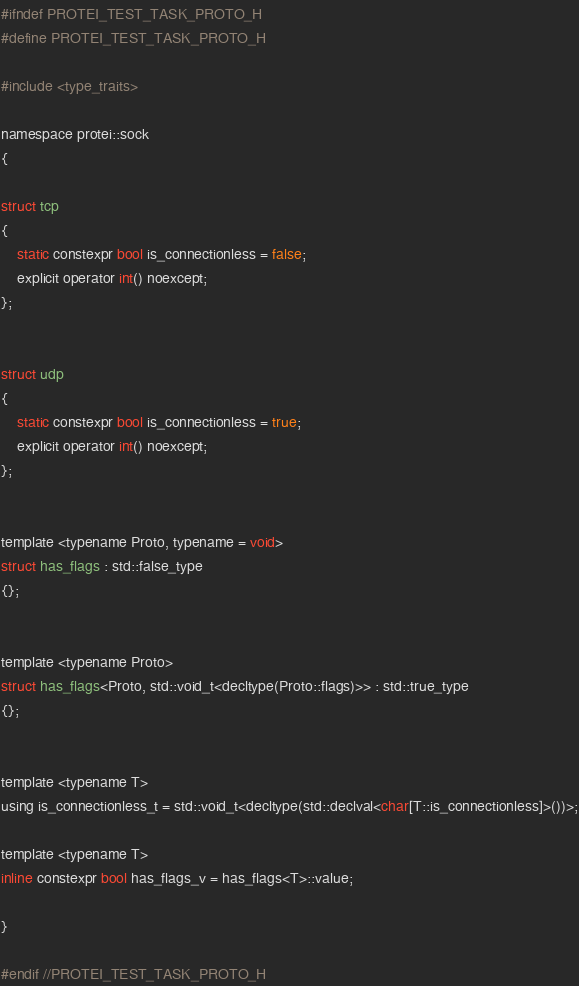Convert code to text. <code><loc_0><loc_0><loc_500><loc_500><_C_>#ifndef PROTEI_TEST_TASK_PROTO_H
#define PROTEI_TEST_TASK_PROTO_H

#include <type_traits>

namespace protei::sock
{

struct tcp
{
    static constexpr bool is_connectionless = false;
    explicit operator int() noexcept;
};


struct udp
{
    static constexpr bool is_connectionless = true;
    explicit operator int() noexcept;
};


template <typename Proto, typename = void>
struct has_flags : std::false_type
{};


template <typename Proto>
struct has_flags<Proto, std::void_t<decltype(Proto::flags)>> : std::true_type
{};


template <typename T>
using is_connectionless_t = std::void_t<decltype(std::declval<char[T::is_connectionless]>())>;

template <typename T>
inline constexpr bool has_flags_v = has_flags<T>::value;

}

#endif //PROTEI_TEST_TASK_PROTO_H
</code> 